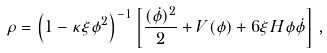Convert formula to latex. <formula><loc_0><loc_0><loc_500><loc_500>\rho = \left ( 1 - \kappa \xi \phi ^ { 2 } \right ) ^ { - 1 } \left [ \frac { ( \dot { \phi } ) ^ { 2 } } { 2 } + V ( \phi ) + 6 \xi H \phi \dot { \phi } \right ] \, ,</formula> 